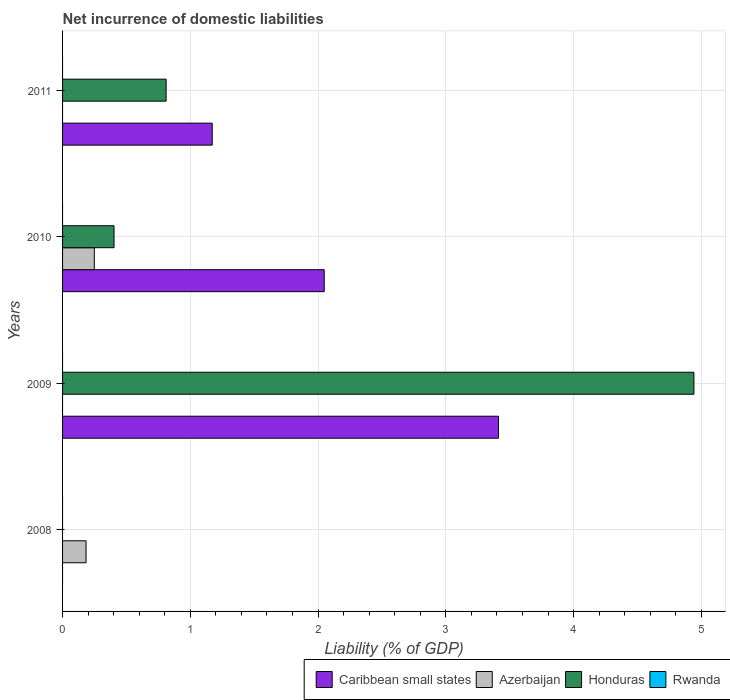How many different coloured bars are there?
Your response must be concise. 3. How many bars are there on the 1st tick from the bottom?
Provide a succinct answer. 1. What is the label of the 3rd group of bars from the top?
Give a very brief answer. 2009. In how many cases, is the number of bars for a given year not equal to the number of legend labels?
Provide a short and direct response. 4. Across all years, what is the maximum net incurrence of domestic liabilities in Azerbaijan?
Offer a very short reply. 0.25. In which year was the net incurrence of domestic liabilities in Caribbean small states maximum?
Your response must be concise. 2009. What is the total net incurrence of domestic liabilities in Caribbean small states in the graph?
Offer a terse response. 6.63. What is the difference between the net incurrence of domestic liabilities in Azerbaijan in 2008 and that in 2010?
Provide a succinct answer. -0.06. What is the difference between the net incurrence of domestic liabilities in Rwanda in 2010 and the net incurrence of domestic liabilities in Caribbean small states in 2011?
Ensure brevity in your answer.  -1.17. What is the average net incurrence of domestic liabilities in Caribbean small states per year?
Your response must be concise. 1.66. What is the ratio of the net incurrence of domestic liabilities in Honduras in 2009 to that in 2010?
Your response must be concise. 12.27. What is the difference between the highest and the second highest net incurrence of domestic liabilities in Caribbean small states?
Your response must be concise. 1.36. What is the difference between the highest and the lowest net incurrence of domestic liabilities in Azerbaijan?
Offer a very short reply. 0.25. Is the sum of the net incurrence of domestic liabilities in Honduras in 2010 and 2011 greater than the maximum net incurrence of domestic liabilities in Caribbean small states across all years?
Your answer should be very brief. No. Is it the case that in every year, the sum of the net incurrence of domestic liabilities in Rwanda and net incurrence of domestic liabilities in Azerbaijan is greater than the net incurrence of domestic liabilities in Caribbean small states?
Make the answer very short. No. How many bars are there?
Your answer should be compact. 8. How many years are there in the graph?
Offer a very short reply. 4. What is the difference between two consecutive major ticks on the X-axis?
Give a very brief answer. 1. Are the values on the major ticks of X-axis written in scientific E-notation?
Ensure brevity in your answer.  No. Does the graph contain any zero values?
Keep it short and to the point. Yes. How are the legend labels stacked?
Your answer should be compact. Horizontal. What is the title of the graph?
Give a very brief answer. Net incurrence of domestic liabilities. What is the label or title of the X-axis?
Provide a short and direct response. Liability (% of GDP). What is the Liability (% of GDP) in Caribbean small states in 2008?
Your response must be concise. 0. What is the Liability (% of GDP) of Azerbaijan in 2008?
Make the answer very short. 0.18. What is the Liability (% of GDP) in Honduras in 2008?
Ensure brevity in your answer.  0. What is the Liability (% of GDP) of Rwanda in 2008?
Offer a terse response. 0. What is the Liability (% of GDP) of Caribbean small states in 2009?
Provide a short and direct response. 3.41. What is the Liability (% of GDP) of Honduras in 2009?
Offer a very short reply. 4.94. What is the Liability (% of GDP) in Caribbean small states in 2010?
Keep it short and to the point. 2.05. What is the Liability (% of GDP) of Azerbaijan in 2010?
Ensure brevity in your answer.  0.25. What is the Liability (% of GDP) of Honduras in 2010?
Ensure brevity in your answer.  0.4. What is the Liability (% of GDP) of Rwanda in 2010?
Provide a succinct answer. 0. What is the Liability (% of GDP) in Caribbean small states in 2011?
Your answer should be very brief. 1.17. What is the Liability (% of GDP) in Honduras in 2011?
Provide a short and direct response. 0.81. What is the Liability (% of GDP) of Rwanda in 2011?
Keep it short and to the point. 0. Across all years, what is the maximum Liability (% of GDP) of Caribbean small states?
Offer a very short reply. 3.41. Across all years, what is the maximum Liability (% of GDP) in Azerbaijan?
Keep it short and to the point. 0.25. Across all years, what is the maximum Liability (% of GDP) of Honduras?
Ensure brevity in your answer.  4.94. Across all years, what is the minimum Liability (% of GDP) in Azerbaijan?
Give a very brief answer. 0. Across all years, what is the minimum Liability (% of GDP) in Honduras?
Ensure brevity in your answer.  0. What is the total Liability (% of GDP) in Caribbean small states in the graph?
Give a very brief answer. 6.63. What is the total Liability (% of GDP) in Azerbaijan in the graph?
Ensure brevity in your answer.  0.43. What is the total Liability (% of GDP) of Honduras in the graph?
Provide a succinct answer. 6.16. What is the difference between the Liability (% of GDP) of Azerbaijan in 2008 and that in 2010?
Give a very brief answer. -0.06. What is the difference between the Liability (% of GDP) of Caribbean small states in 2009 and that in 2010?
Offer a terse response. 1.36. What is the difference between the Liability (% of GDP) in Honduras in 2009 and that in 2010?
Offer a terse response. 4.54. What is the difference between the Liability (% of GDP) of Caribbean small states in 2009 and that in 2011?
Make the answer very short. 2.24. What is the difference between the Liability (% of GDP) in Honduras in 2009 and that in 2011?
Keep it short and to the point. 4.13. What is the difference between the Liability (% of GDP) in Caribbean small states in 2010 and that in 2011?
Your answer should be very brief. 0.88. What is the difference between the Liability (% of GDP) of Honduras in 2010 and that in 2011?
Make the answer very short. -0.41. What is the difference between the Liability (% of GDP) in Azerbaijan in 2008 and the Liability (% of GDP) in Honduras in 2009?
Provide a short and direct response. -4.76. What is the difference between the Liability (% of GDP) of Azerbaijan in 2008 and the Liability (% of GDP) of Honduras in 2010?
Ensure brevity in your answer.  -0.22. What is the difference between the Liability (% of GDP) in Azerbaijan in 2008 and the Liability (% of GDP) in Honduras in 2011?
Give a very brief answer. -0.63. What is the difference between the Liability (% of GDP) in Caribbean small states in 2009 and the Liability (% of GDP) in Azerbaijan in 2010?
Ensure brevity in your answer.  3.16. What is the difference between the Liability (% of GDP) in Caribbean small states in 2009 and the Liability (% of GDP) in Honduras in 2010?
Provide a succinct answer. 3.01. What is the difference between the Liability (% of GDP) in Caribbean small states in 2009 and the Liability (% of GDP) in Honduras in 2011?
Your answer should be compact. 2.6. What is the difference between the Liability (% of GDP) in Caribbean small states in 2010 and the Liability (% of GDP) in Honduras in 2011?
Offer a terse response. 1.24. What is the difference between the Liability (% of GDP) in Azerbaijan in 2010 and the Liability (% of GDP) in Honduras in 2011?
Ensure brevity in your answer.  -0.56. What is the average Liability (% of GDP) in Caribbean small states per year?
Offer a very short reply. 1.66. What is the average Liability (% of GDP) in Azerbaijan per year?
Provide a succinct answer. 0.11. What is the average Liability (% of GDP) in Honduras per year?
Offer a terse response. 1.54. In the year 2009, what is the difference between the Liability (% of GDP) of Caribbean small states and Liability (% of GDP) of Honduras?
Provide a short and direct response. -1.53. In the year 2010, what is the difference between the Liability (% of GDP) of Caribbean small states and Liability (% of GDP) of Azerbaijan?
Make the answer very short. 1.8. In the year 2010, what is the difference between the Liability (% of GDP) of Caribbean small states and Liability (% of GDP) of Honduras?
Give a very brief answer. 1.65. In the year 2010, what is the difference between the Liability (% of GDP) of Azerbaijan and Liability (% of GDP) of Honduras?
Provide a short and direct response. -0.15. In the year 2011, what is the difference between the Liability (% of GDP) of Caribbean small states and Liability (% of GDP) of Honduras?
Ensure brevity in your answer.  0.36. What is the ratio of the Liability (% of GDP) in Azerbaijan in 2008 to that in 2010?
Make the answer very short. 0.74. What is the ratio of the Liability (% of GDP) of Caribbean small states in 2009 to that in 2010?
Provide a succinct answer. 1.67. What is the ratio of the Liability (% of GDP) of Honduras in 2009 to that in 2010?
Your response must be concise. 12.27. What is the ratio of the Liability (% of GDP) in Caribbean small states in 2009 to that in 2011?
Keep it short and to the point. 2.91. What is the ratio of the Liability (% of GDP) in Honduras in 2009 to that in 2011?
Provide a short and direct response. 6.1. What is the ratio of the Liability (% of GDP) in Caribbean small states in 2010 to that in 2011?
Your answer should be very brief. 1.75. What is the ratio of the Liability (% of GDP) in Honduras in 2010 to that in 2011?
Provide a short and direct response. 0.5. What is the difference between the highest and the second highest Liability (% of GDP) in Caribbean small states?
Your answer should be very brief. 1.36. What is the difference between the highest and the second highest Liability (% of GDP) in Honduras?
Provide a short and direct response. 4.13. What is the difference between the highest and the lowest Liability (% of GDP) in Caribbean small states?
Provide a succinct answer. 3.41. What is the difference between the highest and the lowest Liability (% of GDP) in Azerbaijan?
Your answer should be compact. 0.25. What is the difference between the highest and the lowest Liability (% of GDP) in Honduras?
Your response must be concise. 4.94. 